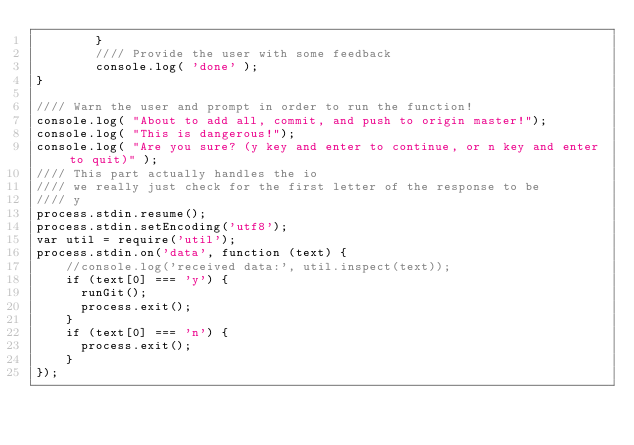<code> <loc_0><loc_0><loc_500><loc_500><_JavaScript_>        }
        //// Provide the user with some feedback
        console.log( 'done' );}//// Warn the user and prompt in order to run the function!console.log( "About to add all, commit, and push to origin master!");
console.log( "This is dangerous!");
console.log( "Are you sure? (y key and enter to continue, or n key and enter to quit)" );//// This part actually handles the io//// we really just check for the first letter of the response to be//// yprocess.stdin.resume();
process.stdin.setEncoding('utf8');
var util = require('util');
process.stdin.on('data', function (text) {
    //console.log('received data:', util.inspect(text));
    if (text[0] === 'y') {
      runGit();
      process.exit();
    }
    if (text[0] === 'n') {
      process.exit();
    }
});
</code> 